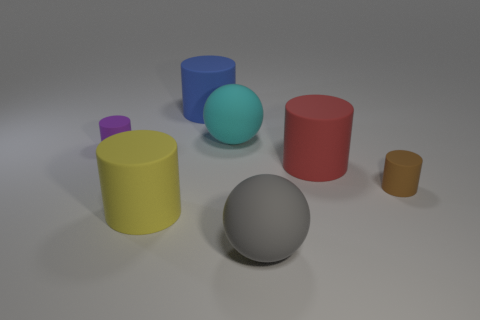Is the material of the tiny cylinder behind the red rubber thing the same as the yellow thing?
Offer a very short reply. Yes. What color is the object that is on the left side of the blue matte object and right of the tiny purple rubber cylinder?
Offer a terse response. Yellow. There is a big cylinder that is to the right of the blue matte thing; how many large matte spheres are to the left of it?
Your answer should be compact. 2. How many objects are small purple rubber cylinders or tiny red rubber balls?
Make the answer very short. 1. There is a small rubber object that is to the left of the large ball that is behind the small purple object; what is its shape?
Provide a succinct answer. Cylinder. What number of other things are there of the same material as the brown thing
Ensure brevity in your answer.  6. Is the material of the purple cylinder the same as the large ball behind the purple matte cylinder?
Your response must be concise. Yes. How many things are tiny rubber things that are to the right of the big red cylinder or things on the right side of the purple cylinder?
Keep it short and to the point. 6. Are there more objects right of the small purple object than yellow objects that are to the right of the large yellow rubber cylinder?
Ensure brevity in your answer.  Yes. What number of balls are either large brown rubber objects or blue objects?
Provide a short and direct response. 0. 